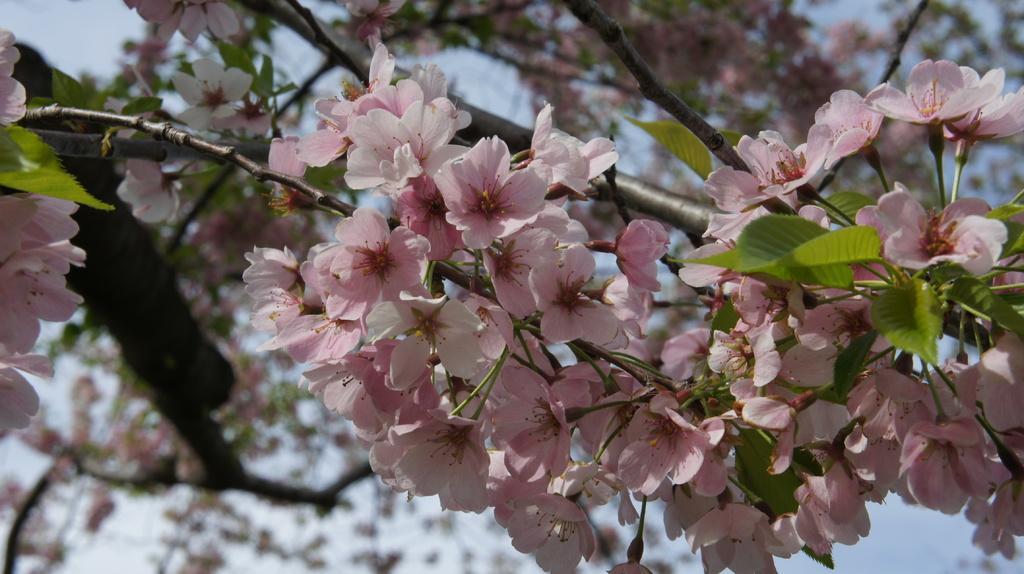Can you describe this image briefly? In the picture I can see some group of flowers to the tree. 